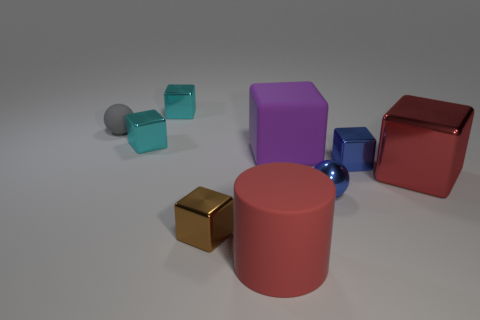What number of other things are there of the same shape as the small brown metal object?
Your response must be concise. 5. What is the shape of the red object right of the large purple matte thing?
Offer a very short reply. Cube. What is the color of the big rubber cube?
Your answer should be very brief. Purple. How many other things are there of the same size as the gray sphere?
Offer a very short reply. 5. What material is the thing that is left of the tiny cyan metallic cube in front of the gray ball?
Make the answer very short. Rubber. There is a brown metallic block; does it have the same size as the rubber thing left of the cylinder?
Offer a very short reply. Yes. Is there a matte cube that has the same color as the large metallic block?
Offer a terse response. No. How many big objects are red shiny balls or red objects?
Your response must be concise. 2. How many purple objects are there?
Offer a very short reply. 1. What is the material of the tiny block right of the large rubber cylinder?
Ensure brevity in your answer.  Metal. 